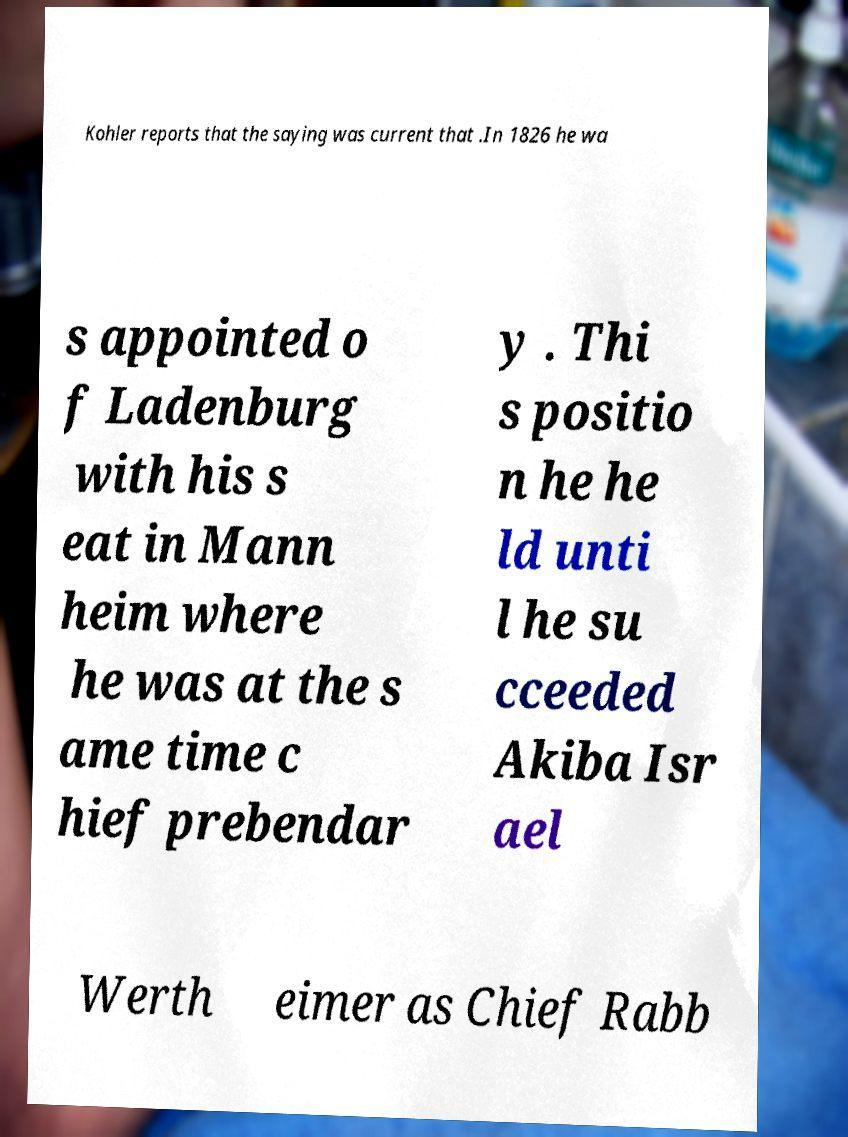Please read and relay the text visible in this image. What does it say? Kohler reports that the saying was current that .In 1826 he wa s appointed o f Ladenburg with his s eat in Mann heim where he was at the s ame time c hief prebendar y . Thi s positio n he he ld unti l he su cceeded Akiba Isr ael Werth eimer as Chief Rabb 